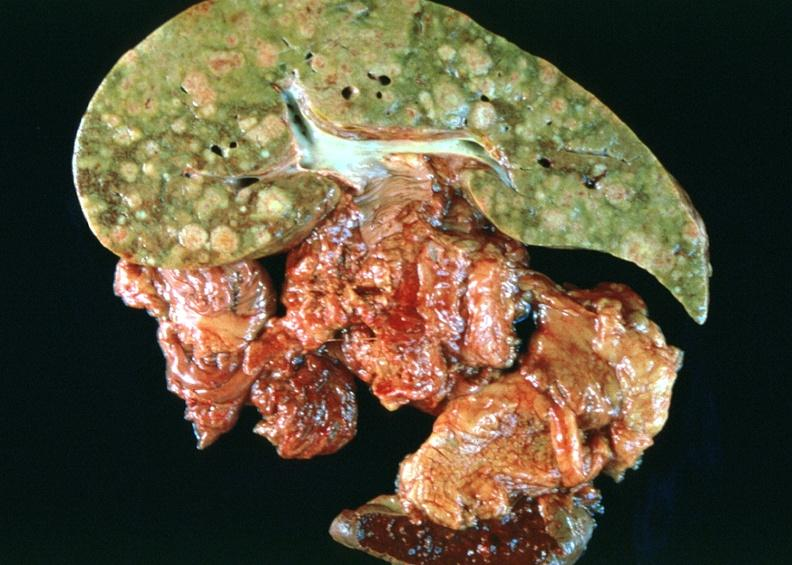what does this image show?
Answer the question using a single word or phrase. Breast cancer metastasis to liver 